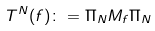Convert formula to latex. <formula><loc_0><loc_0><loc_500><loc_500>T ^ { N } ( f ) \colon = \Pi _ { N } M _ { f } \Pi _ { N }</formula> 